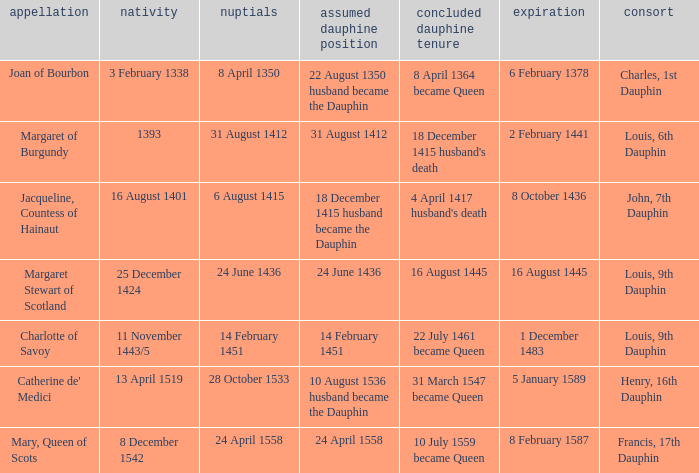When was became dauphine when birth is 1393? 31 August 1412. 